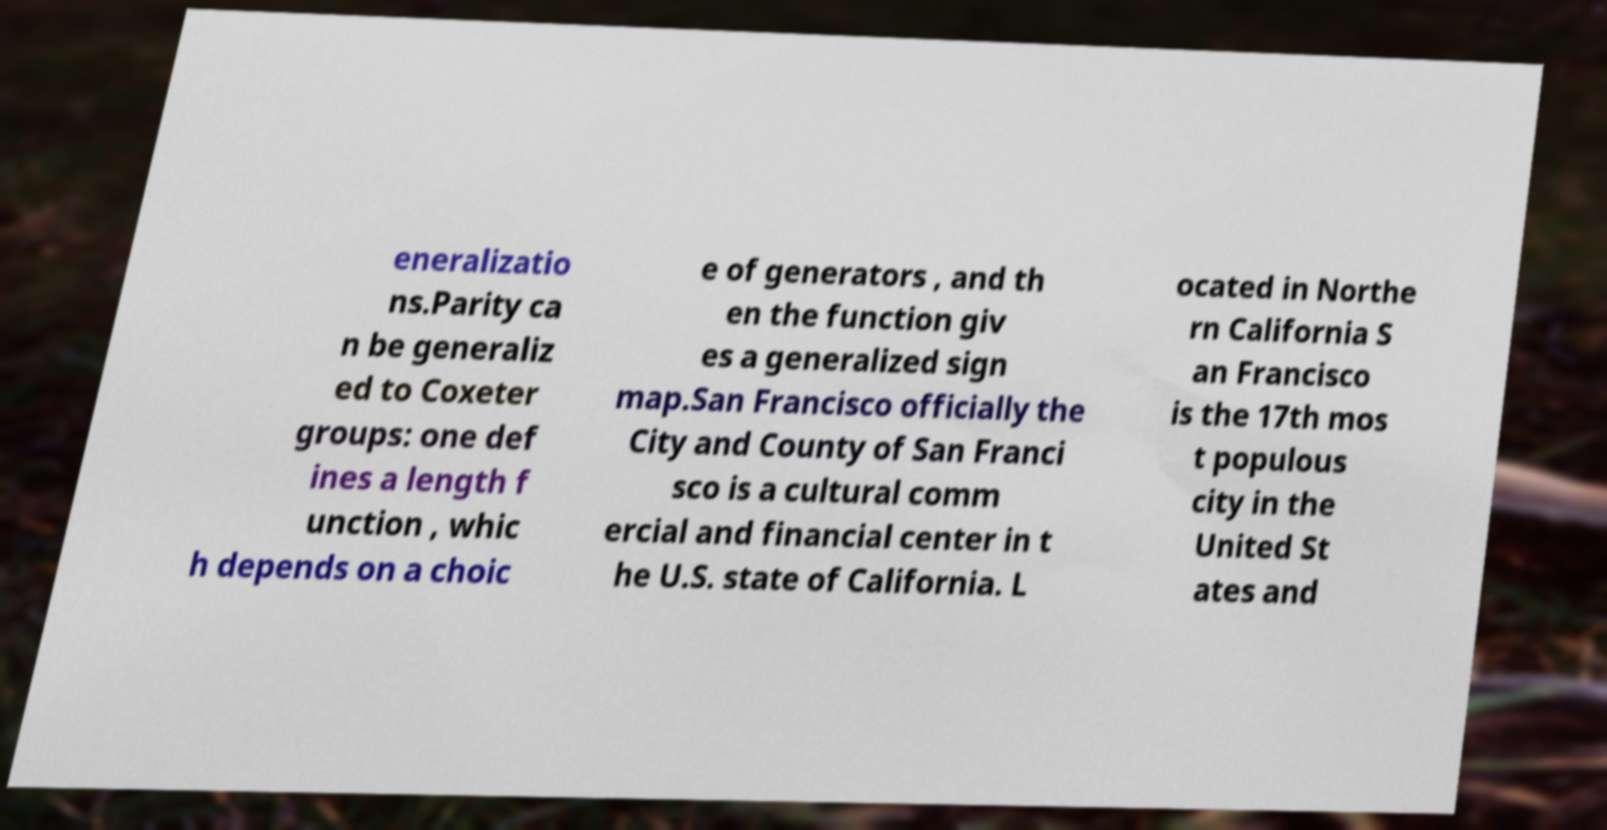What messages or text are displayed in this image? I need them in a readable, typed format. eneralizatio ns.Parity ca n be generaliz ed to Coxeter groups: one def ines a length f unction , whic h depends on a choic e of generators , and th en the function giv es a generalized sign map.San Francisco officially the City and County of San Franci sco is a cultural comm ercial and financial center in t he U.S. state of California. L ocated in Northe rn California S an Francisco is the 17th mos t populous city in the United St ates and 